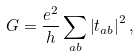Convert formula to latex. <formula><loc_0><loc_0><loc_500><loc_500>G = \frac { e ^ { 2 } } { h } \sum _ { a b } \left | t _ { a b } \right | ^ { 2 } ,</formula> 